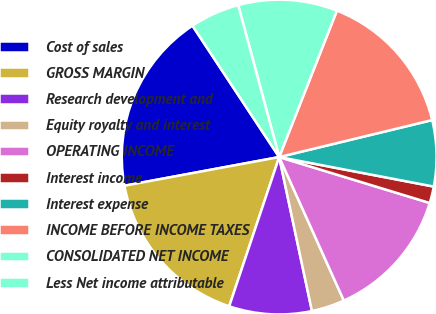Convert chart. <chart><loc_0><loc_0><loc_500><loc_500><pie_chart><fcel>Cost of sales<fcel>GROSS MARGIN<fcel>Research development and<fcel>Equity royalty and interest<fcel>OPERATING INCOME<fcel>Interest income<fcel>Interest expense<fcel>INCOME BEFORE INCOME TAXES<fcel>CONSOLIDATED NET INCOME<fcel>Less Net income attributable<nl><fcel>18.63%<fcel>16.94%<fcel>8.48%<fcel>3.4%<fcel>13.55%<fcel>1.71%<fcel>6.78%<fcel>15.25%<fcel>10.17%<fcel>5.09%<nl></chart> 